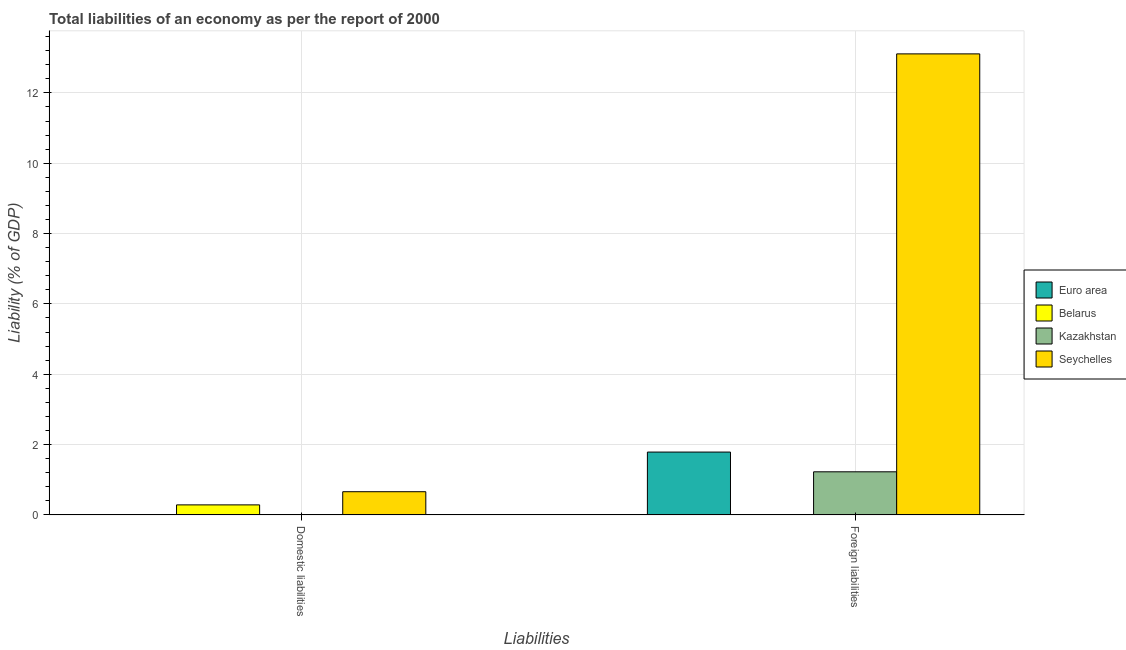How many groups of bars are there?
Your response must be concise. 2. Are the number of bars per tick equal to the number of legend labels?
Your response must be concise. No. How many bars are there on the 1st tick from the left?
Your answer should be very brief. 2. How many bars are there on the 1st tick from the right?
Provide a short and direct response. 3. What is the label of the 2nd group of bars from the left?
Provide a short and direct response. Foreign liabilities. What is the incurrence of domestic liabilities in Belarus?
Offer a terse response. 0.29. Across all countries, what is the maximum incurrence of foreign liabilities?
Ensure brevity in your answer.  13.11. In which country was the incurrence of foreign liabilities maximum?
Your answer should be very brief. Seychelles. What is the total incurrence of foreign liabilities in the graph?
Provide a succinct answer. 16.12. What is the difference between the incurrence of foreign liabilities in Seychelles and the incurrence of domestic liabilities in Euro area?
Your answer should be very brief. 13.11. What is the average incurrence of domestic liabilities per country?
Keep it short and to the point. 0.24. What is the difference between the incurrence of domestic liabilities and incurrence of foreign liabilities in Seychelles?
Your response must be concise. -12.45. In how many countries, is the incurrence of domestic liabilities greater than 13.2 %?
Offer a terse response. 0. What is the ratio of the incurrence of foreign liabilities in Seychelles to that in Euro area?
Your response must be concise. 7.33. In how many countries, is the incurrence of foreign liabilities greater than the average incurrence of foreign liabilities taken over all countries?
Your answer should be compact. 1. Are all the bars in the graph horizontal?
Ensure brevity in your answer.  No. Are the values on the major ticks of Y-axis written in scientific E-notation?
Provide a succinct answer. No. Does the graph contain grids?
Ensure brevity in your answer.  Yes. Where does the legend appear in the graph?
Give a very brief answer. Center right. How are the legend labels stacked?
Offer a terse response. Vertical. What is the title of the graph?
Your response must be concise. Total liabilities of an economy as per the report of 2000. Does "Chad" appear as one of the legend labels in the graph?
Provide a succinct answer. No. What is the label or title of the X-axis?
Offer a very short reply. Liabilities. What is the label or title of the Y-axis?
Offer a very short reply. Liability (% of GDP). What is the Liability (% of GDP) of Belarus in Domestic liabilities?
Keep it short and to the point. 0.29. What is the Liability (% of GDP) of Seychelles in Domestic liabilities?
Your answer should be compact. 0.66. What is the Liability (% of GDP) of Euro area in Foreign liabilities?
Make the answer very short. 1.79. What is the Liability (% of GDP) in Kazakhstan in Foreign liabilities?
Offer a terse response. 1.23. What is the Liability (% of GDP) in Seychelles in Foreign liabilities?
Make the answer very short. 13.11. Across all Liabilities, what is the maximum Liability (% of GDP) in Euro area?
Your answer should be very brief. 1.79. Across all Liabilities, what is the maximum Liability (% of GDP) of Belarus?
Provide a succinct answer. 0.29. Across all Liabilities, what is the maximum Liability (% of GDP) in Kazakhstan?
Ensure brevity in your answer.  1.23. Across all Liabilities, what is the maximum Liability (% of GDP) of Seychelles?
Your response must be concise. 13.11. Across all Liabilities, what is the minimum Liability (% of GDP) of Euro area?
Provide a succinct answer. 0. Across all Liabilities, what is the minimum Liability (% of GDP) of Belarus?
Offer a terse response. 0. Across all Liabilities, what is the minimum Liability (% of GDP) in Seychelles?
Your response must be concise. 0.66. What is the total Liability (% of GDP) in Euro area in the graph?
Offer a very short reply. 1.79. What is the total Liability (% of GDP) of Belarus in the graph?
Your answer should be very brief. 0.29. What is the total Liability (% of GDP) of Kazakhstan in the graph?
Offer a terse response. 1.23. What is the total Liability (% of GDP) in Seychelles in the graph?
Make the answer very short. 13.77. What is the difference between the Liability (% of GDP) in Seychelles in Domestic liabilities and that in Foreign liabilities?
Give a very brief answer. -12.45. What is the difference between the Liability (% of GDP) in Belarus in Domestic liabilities and the Liability (% of GDP) in Kazakhstan in Foreign liabilities?
Make the answer very short. -0.94. What is the difference between the Liability (% of GDP) of Belarus in Domestic liabilities and the Liability (% of GDP) of Seychelles in Foreign liabilities?
Give a very brief answer. -12.82. What is the average Liability (% of GDP) of Euro area per Liabilities?
Your answer should be very brief. 0.89. What is the average Liability (% of GDP) in Belarus per Liabilities?
Make the answer very short. 0.14. What is the average Liability (% of GDP) of Kazakhstan per Liabilities?
Provide a succinct answer. 0.61. What is the average Liability (% of GDP) in Seychelles per Liabilities?
Provide a succinct answer. 6.89. What is the difference between the Liability (% of GDP) of Belarus and Liability (% of GDP) of Seychelles in Domestic liabilities?
Your answer should be very brief. -0.37. What is the difference between the Liability (% of GDP) in Euro area and Liability (% of GDP) in Kazakhstan in Foreign liabilities?
Your answer should be very brief. 0.56. What is the difference between the Liability (% of GDP) of Euro area and Liability (% of GDP) of Seychelles in Foreign liabilities?
Offer a terse response. -11.32. What is the difference between the Liability (% of GDP) of Kazakhstan and Liability (% of GDP) of Seychelles in Foreign liabilities?
Provide a short and direct response. -11.88. What is the ratio of the Liability (% of GDP) in Seychelles in Domestic liabilities to that in Foreign liabilities?
Your answer should be compact. 0.05. What is the difference between the highest and the second highest Liability (% of GDP) of Seychelles?
Keep it short and to the point. 12.45. What is the difference between the highest and the lowest Liability (% of GDP) in Euro area?
Give a very brief answer. 1.79. What is the difference between the highest and the lowest Liability (% of GDP) of Belarus?
Provide a short and direct response. 0.29. What is the difference between the highest and the lowest Liability (% of GDP) in Kazakhstan?
Give a very brief answer. 1.23. What is the difference between the highest and the lowest Liability (% of GDP) of Seychelles?
Provide a succinct answer. 12.45. 